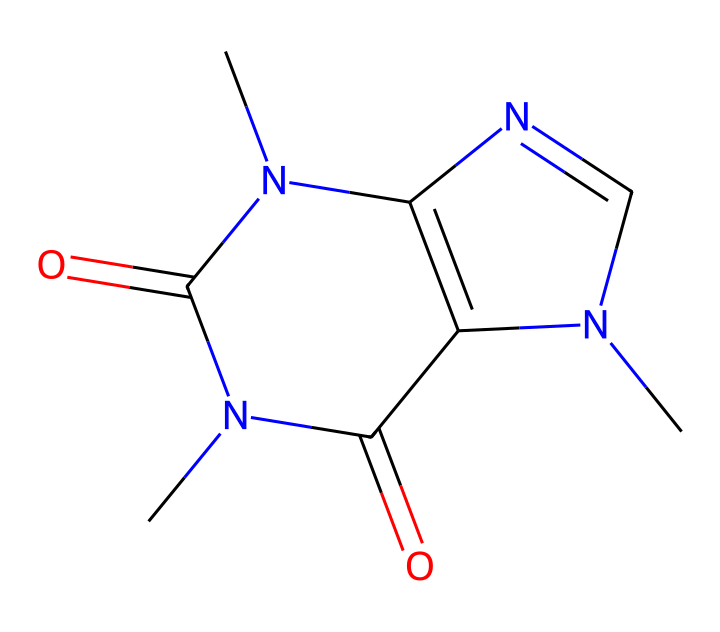What is the molecular formula of caffeine? To determine the molecular formula from the SMILES representation, we identify the types and numbers of atoms present in the structure. The following atoms are visible: Carbon (C), Nitrogen (N), and Oxygen (O). Counting these gives us: C: 8, H: 10, N: 4, O: 2. Thus, the molecular formula is C8H10N4O2.
Answer: C8H10N4O2 How many nitrogen atoms are in caffeine? By examining the SMILES structure, I count the nitrogen atoms present. There are four nitrogen atoms in the chemical structure.
Answer: 4 What type of compound is caffeine? Caffeine is classified as an alkaloid based on its structure, which includes multiple nitrogen atoms arranged in a fused ring system characteristic of many alkaloids.
Answer: alkaloid What is the total number of rings in caffeine's structure? Analyzing the structure, caffeine consists of two fused rings in its molecular arrangement. This can be deduced from the cyclic forms present in the SMILES representation.
Answer: 2 What functional groups are present in caffeine? By observing the SMILES representation, caffeine has two carbonyl (C=O) functional groups and amine groups due to the presence of nitrogen. These indicate the types of reactivity caffeine can have.
Answer: carbonyl and amine Is caffeine a polar or nonpolar molecule? Considering the presence of polar functional groups such as amines and carbonyls, and the overall structure with various electronegative atoms, caffeine is polar.
Answer: polar 